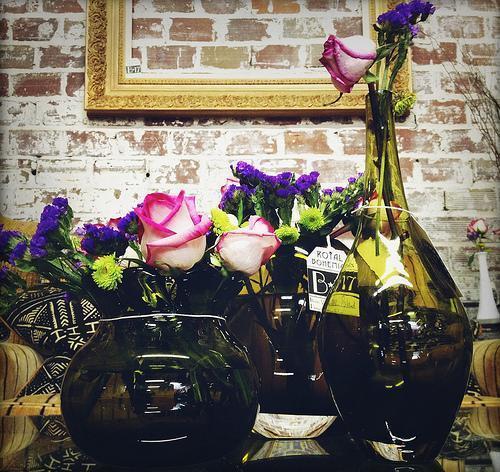How many vases?
Give a very brief answer. 3. 